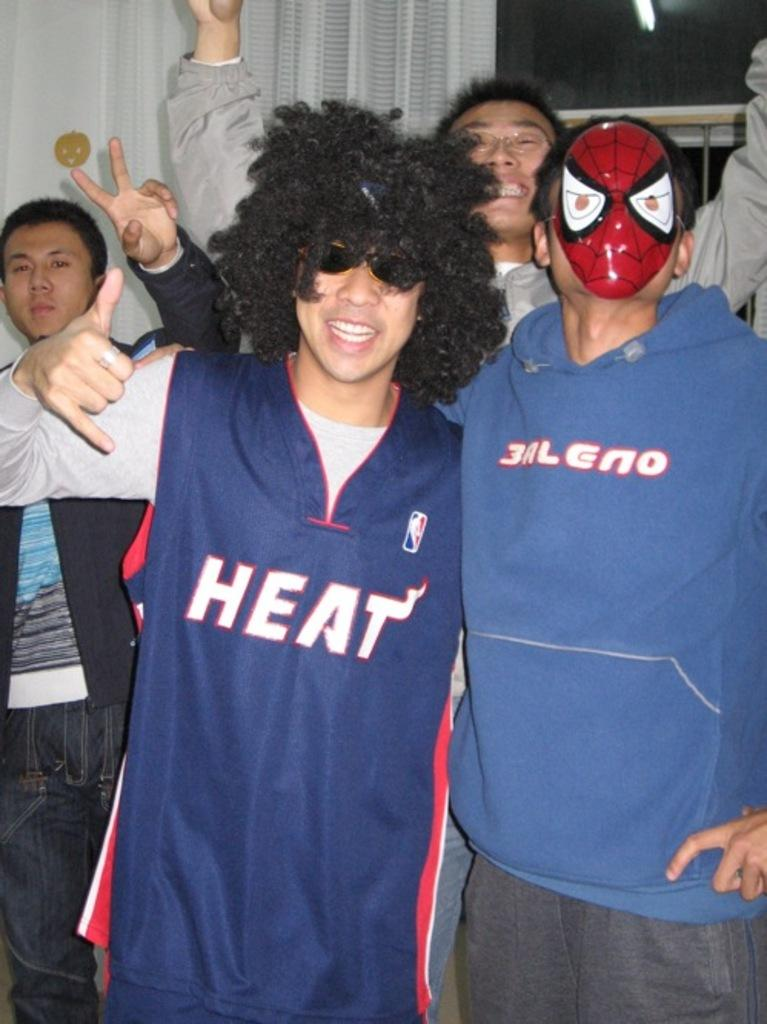<image>
Render a clear and concise summary of the photo. Man wearing an afro and a jersey that says HEAT on it. 